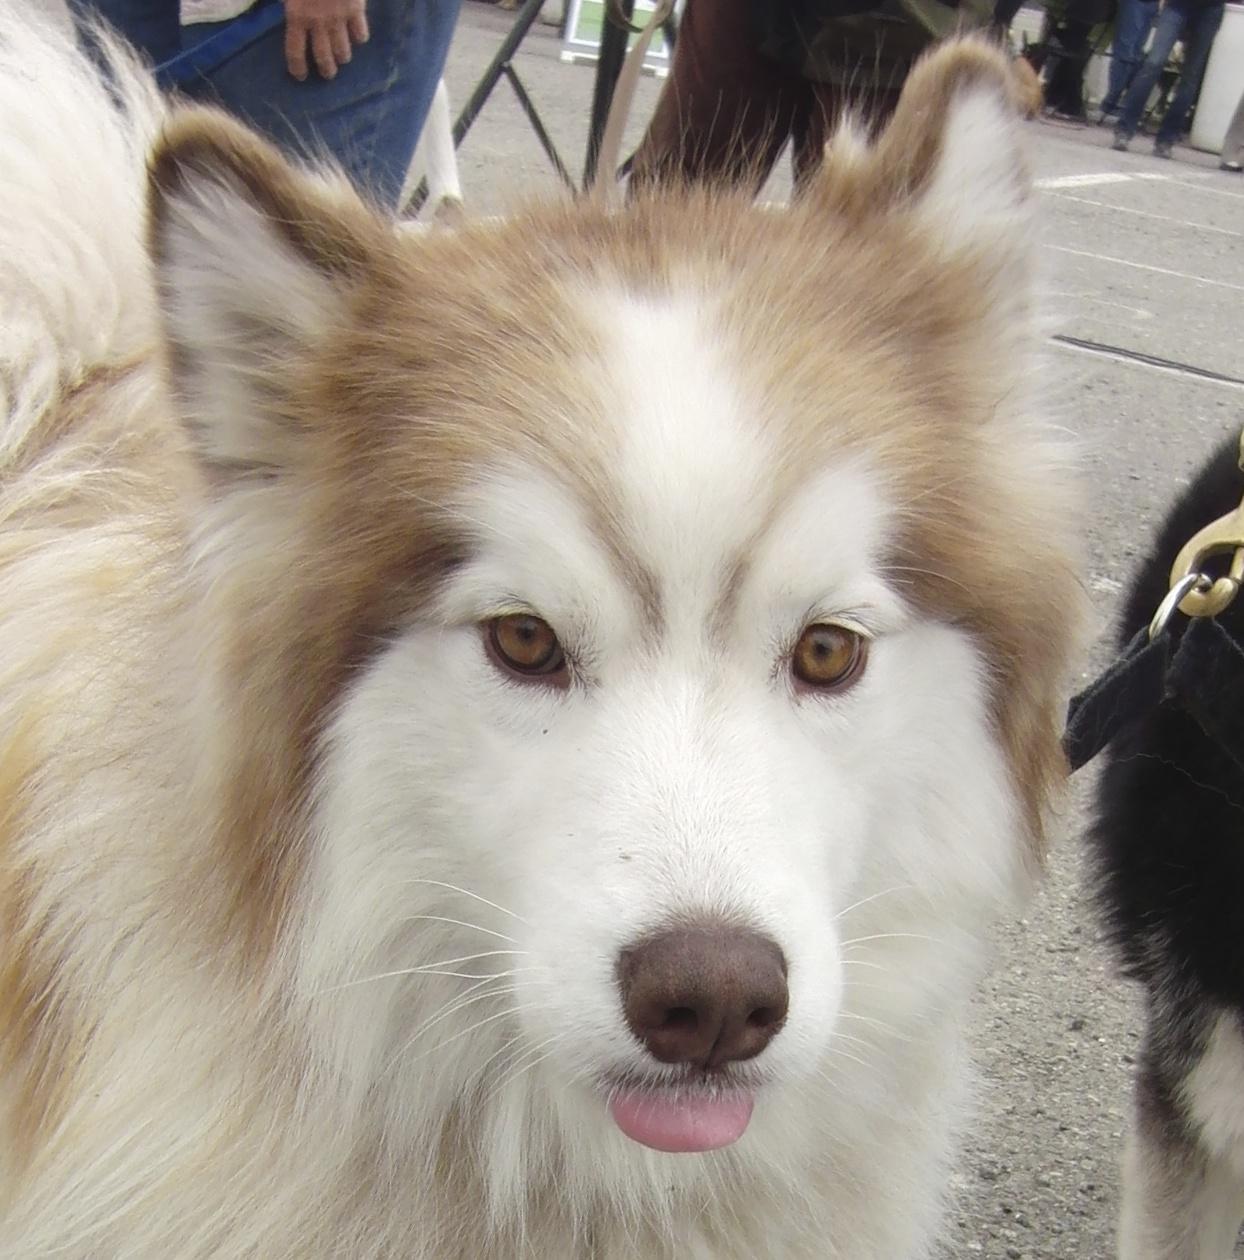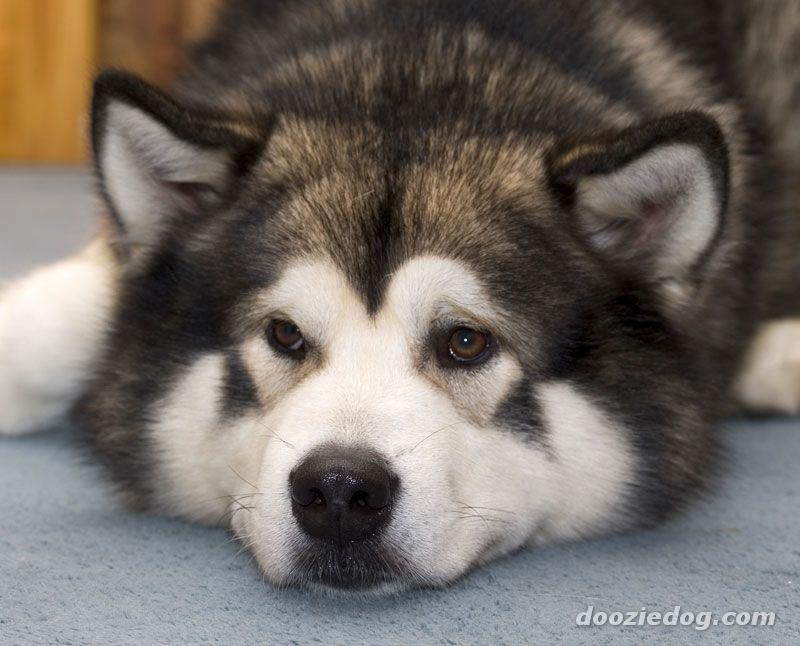The first image is the image on the left, the second image is the image on the right. Evaluate the accuracy of this statement regarding the images: "There are two Huskies in one image and a single Husky in another image.". Is it true? Answer yes or no. No. The first image is the image on the left, the second image is the image on the right. Considering the images on both sides, is "The left image contains two side-by-side puppies who are facing forward and sitting upright." valid? Answer yes or no. No. 